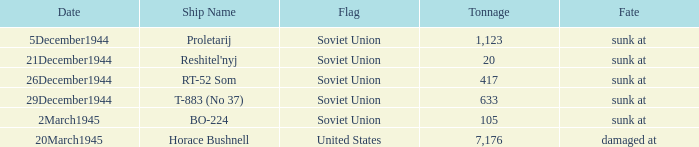How did the ship named proletarij finish its service? Sunk at. 